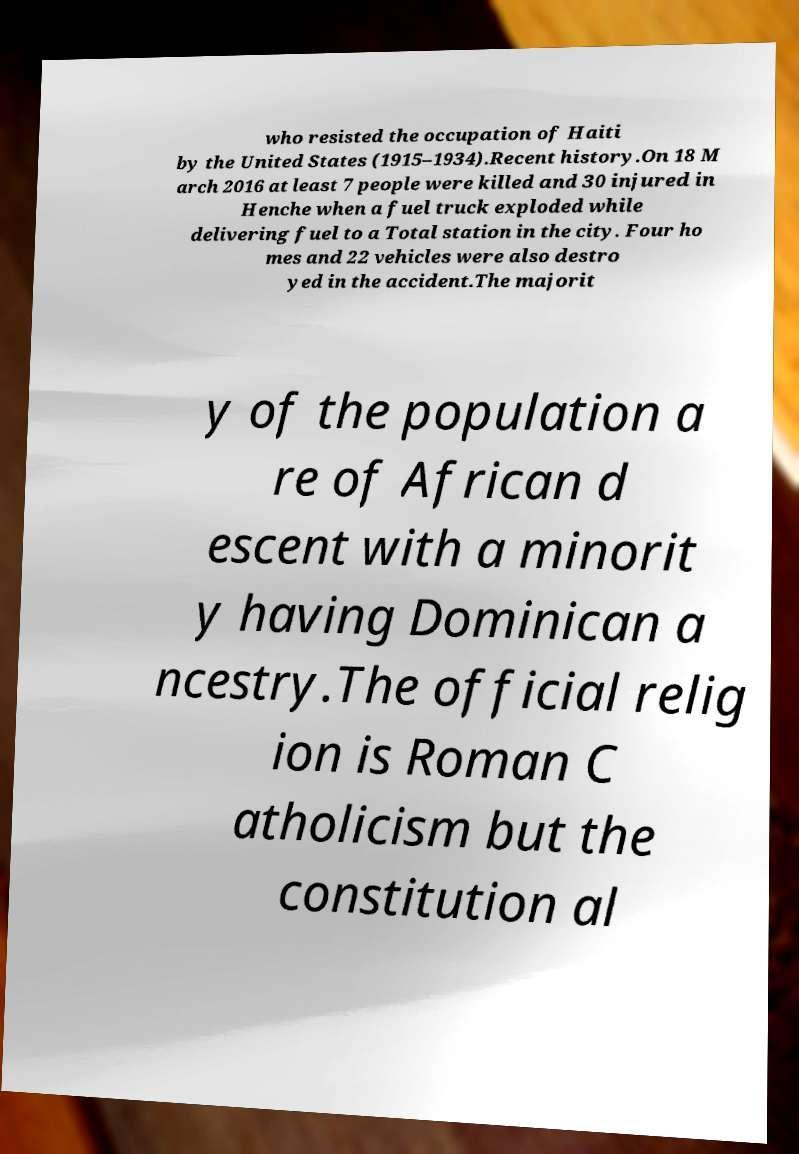Can you read and provide the text displayed in the image?This photo seems to have some interesting text. Can you extract and type it out for me? who resisted the occupation of Haiti by the United States (1915–1934).Recent history.On 18 M arch 2016 at least 7 people were killed and 30 injured in Henche when a fuel truck exploded while delivering fuel to a Total station in the city. Four ho mes and 22 vehicles were also destro yed in the accident.The majorit y of the population a re of African d escent with a minorit y having Dominican a ncestry.The official relig ion is Roman C atholicism but the constitution al 